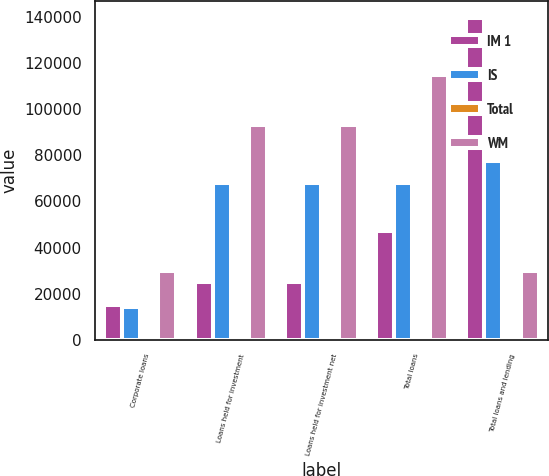<chart> <loc_0><loc_0><loc_500><loc_500><stacked_bar_chart><ecel><fcel>Corporate loans<fcel>Loans held for investment<fcel>Loans held for investment net<fcel>Total loans<fcel>Total loans and lending<nl><fcel>IM 1<fcel>15332<fcel>25312<fcel>25130<fcel>46983<fcel>139571<nl><fcel>IS<fcel>14417<fcel>67860<fcel>67818<fcel>67852<fcel>77333<nl><fcel>Total<fcel>5<fcel>5<fcel>5<fcel>27<fcel>27<nl><fcel>WM<fcel>29754<fcel>93177<fcel>92953<fcel>114862<fcel>29754<nl></chart> 